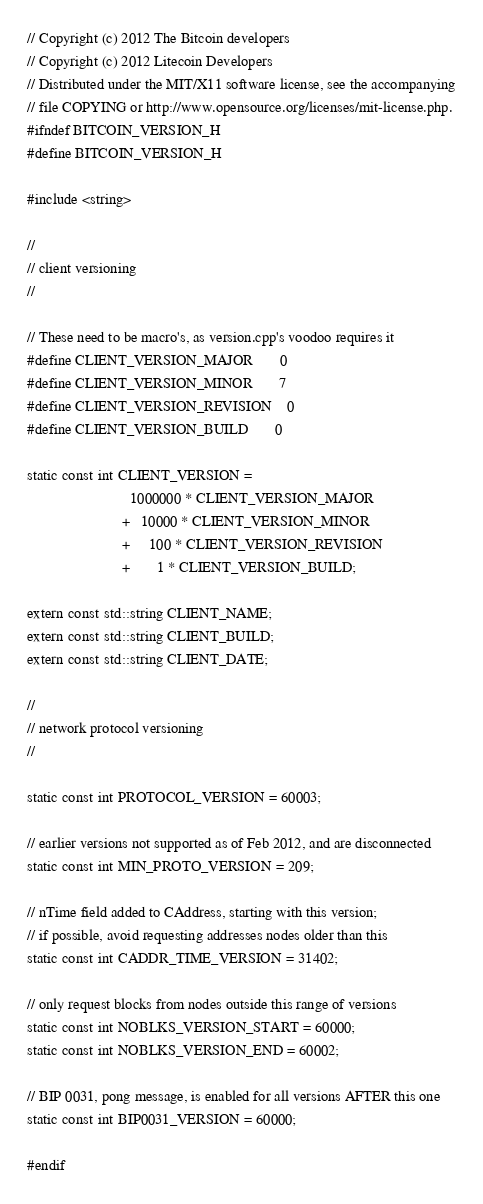Convert code to text. <code><loc_0><loc_0><loc_500><loc_500><_C_>// Copyright (c) 2012 The Bitcoin developers
// Copyright (c) 2012 Litecoin Developers
// Distributed under the MIT/X11 software license, see the accompanying
// file COPYING or http://www.opensource.org/licenses/mit-license.php.
#ifndef BITCOIN_VERSION_H
#define BITCOIN_VERSION_H

#include <string>

//
// client versioning
//

// These need to be macro's, as version.cpp's voodoo requires it
#define CLIENT_VERSION_MAJOR       0
#define CLIENT_VERSION_MINOR       7
#define CLIENT_VERSION_REVISION    0
#define CLIENT_VERSION_BUILD       0

static const int CLIENT_VERSION =
                           1000000 * CLIENT_VERSION_MAJOR
                         +   10000 * CLIENT_VERSION_MINOR 
                         +     100 * CLIENT_VERSION_REVISION
                         +       1 * CLIENT_VERSION_BUILD;

extern const std::string CLIENT_NAME;
extern const std::string CLIENT_BUILD;
extern const std::string CLIENT_DATE;

//
// network protocol versioning
//

static const int PROTOCOL_VERSION = 60003;

// earlier versions not supported as of Feb 2012, and are disconnected
static const int MIN_PROTO_VERSION = 209;

// nTime field added to CAddress, starting with this version;
// if possible, avoid requesting addresses nodes older than this
static const int CADDR_TIME_VERSION = 31402;

// only request blocks from nodes outside this range of versions
static const int NOBLKS_VERSION_START = 60000;
static const int NOBLKS_VERSION_END = 60002;

// BIP 0031, pong message, is enabled for all versions AFTER this one
static const int BIP0031_VERSION = 60000;

#endif
</code> 